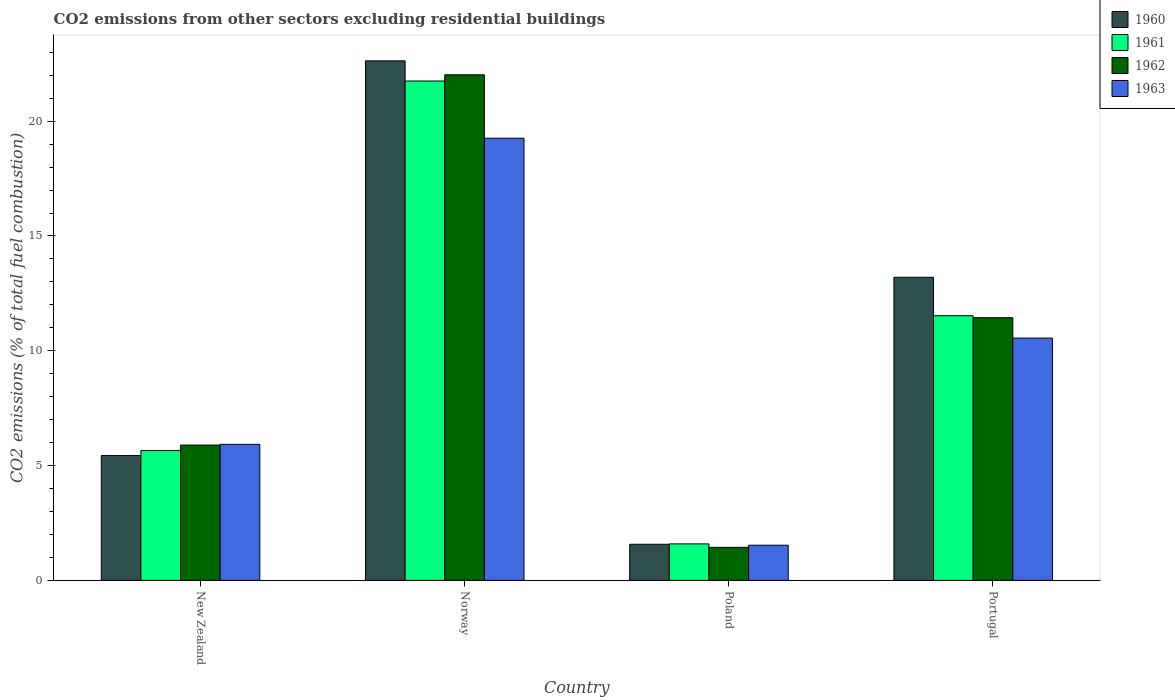Are the number of bars per tick equal to the number of legend labels?
Your response must be concise. Yes. How many bars are there on the 1st tick from the right?
Offer a terse response. 4. What is the label of the 1st group of bars from the left?
Your response must be concise. New Zealand. What is the total CO2 emitted in 1963 in Norway?
Ensure brevity in your answer.  19.26. Across all countries, what is the maximum total CO2 emitted in 1960?
Make the answer very short. 22.63. Across all countries, what is the minimum total CO2 emitted in 1961?
Offer a very short reply. 1.59. In which country was the total CO2 emitted in 1961 maximum?
Your answer should be compact. Norway. What is the total total CO2 emitted in 1961 in the graph?
Ensure brevity in your answer.  40.52. What is the difference between the total CO2 emitted in 1963 in Poland and that in Portugal?
Your answer should be very brief. -9.02. What is the difference between the total CO2 emitted in 1960 in New Zealand and the total CO2 emitted in 1963 in Portugal?
Your answer should be compact. -5.12. What is the average total CO2 emitted in 1961 per country?
Your response must be concise. 10.13. What is the difference between the total CO2 emitted of/in 1962 and total CO2 emitted of/in 1961 in Norway?
Your answer should be very brief. 0.27. In how many countries, is the total CO2 emitted in 1961 greater than 18?
Offer a terse response. 1. What is the ratio of the total CO2 emitted in 1960 in Poland to that in Portugal?
Ensure brevity in your answer.  0.12. Is the difference between the total CO2 emitted in 1962 in New Zealand and Poland greater than the difference between the total CO2 emitted in 1961 in New Zealand and Poland?
Offer a very short reply. Yes. What is the difference between the highest and the second highest total CO2 emitted in 1963?
Provide a succinct answer. -8.7. What is the difference between the highest and the lowest total CO2 emitted in 1962?
Ensure brevity in your answer.  20.58. In how many countries, is the total CO2 emitted in 1963 greater than the average total CO2 emitted in 1963 taken over all countries?
Your answer should be very brief. 2. What does the 2nd bar from the left in New Zealand represents?
Offer a terse response. 1961. What does the 2nd bar from the right in New Zealand represents?
Your response must be concise. 1962. Are all the bars in the graph horizontal?
Offer a very short reply. No. How many countries are there in the graph?
Offer a terse response. 4. What is the difference between two consecutive major ticks on the Y-axis?
Keep it short and to the point. 5. Are the values on the major ticks of Y-axis written in scientific E-notation?
Offer a very short reply. No. Where does the legend appear in the graph?
Your response must be concise. Top right. What is the title of the graph?
Your answer should be very brief. CO2 emissions from other sectors excluding residential buildings. Does "1996" appear as one of the legend labels in the graph?
Ensure brevity in your answer.  No. What is the label or title of the X-axis?
Keep it short and to the point. Country. What is the label or title of the Y-axis?
Your response must be concise. CO2 emissions (% of total fuel combustion). What is the CO2 emissions (% of total fuel combustion) in 1960 in New Zealand?
Make the answer very short. 5.44. What is the CO2 emissions (% of total fuel combustion) of 1961 in New Zealand?
Your answer should be compact. 5.66. What is the CO2 emissions (% of total fuel combustion) of 1962 in New Zealand?
Offer a very short reply. 5.89. What is the CO2 emissions (% of total fuel combustion) of 1963 in New Zealand?
Give a very brief answer. 5.93. What is the CO2 emissions (% of total fuel combustion) of 1960 in Norway?
Provide a succinct answer. 22.63. What is the CO2 emissions (% of total fuel combustion) of 1961 in Norway?
Give a very brief answer. 21.75. What is the CO2 emissions (% of total fuel combustion) of 1962 in Norway?
Provide a succinct answer. 22.02. What is the CO2 emissions (% of total fuel combustion) of 1963 in Norway?
Offer a terse response. 19.26. What is the CO2 emissions (% of total fuel combustion) in 1960 in Poland?
Offer a very short reply. 1.57. What is the CO2 emissions (% of total fuel combustion) of 1961 in Poland?
Make the answer very short. 1.59. What is the CO2 emissions (% of total fuel combustion) of 1962 in Poland?
Provide a short and direct response. 1.44. What is the CO2 emissions (% of total fuel combustion) in 1963 in Poland?
Provide a short and direct response. 1.53. What is the CO2 emissions (% of total fuel combustion) of 1960 in Portugal?
Keep it short and to the point. 13.2. What is the CO2 emissions (% of total fuel combustion) of 1961 in Portugal?
Provide a short and direct response. 11.53. What is the CO2 emissions (% of total fuel combustion) of 1962 in Portugal?
Give a very brief answer. 11.44. What is the CO2 emissions (% of total fuel combustion) of 1963 in Portugal?
Your response must be concise. 10.55. Across all countries, what is the maximum CO2 emissions (% of total fuel combustion) of 1960?
Make the answer very short. 22.63. Across all countries, what is the maximum CO2 emissions (% of total fuel combustion) in 1961?
Your answer should be very brief. 21.75. Across all countries, what is the maximum CO2 emissions (% of total fuel combustion) of 1962?
Provide a succinct answer. 22.02. Across all countries, what is the maximum CO2 emissions (% of total fuel combustion) in 1963?
Your answer should be very brief. 19.26. Across all countries, what is the minimum CO2 emissions (% of total fuel combustion) of 1960?
Your response must be concise. 1.57. Across all countries, what is the minimum CO2 emissions (% of total fuel combustion) of 1961?
Your answer should be very brief. 1.59. Across all countries, what is the minimum CO2 emissions (% of total fuel combustion) of 1962?
Offer a very short reply. 1.44. Across all countries, what is the minimum CO2 emissions (% of total fuel combustion) in 1963?
Make the answer very short. 1.53. What is the total CO2 emissions (% of total fuel combustion) of 1960 in the graph?
Make the answer very short. 42.84. What is the total CO2 emissions (% of total fuel combustion) in 1961 in the graph?
Give a very brief answer. 40.52. What is the total CO2 emissions (% of total fuel combustion) of 1962 in the graph?
Offer a terse response. 40.79. What is the total CO2 emissions (% of total fuel combustion) in 1963 in the graph?
Provide a short and direct response. 37.27. What is the difference between the CO2 emissions (% of total fuel combustion) in 1960 in New Zealand and that in Norway?
Your response must be concise. -17.19. What is the difference between the CO2 emissions (% of total fuel combustion) in 1961 in New Zealand and that in Norway?
Provide a succinct answer. -16.09. What is the difference between the CO2 emissions (% of total fuel combustion) of 1962 in New Zealand and that in Norway?
Your answer should be very brief. -16.13. What is the difference between the CO2 emissions (% of total fuel combustion) of 1963 in New Zealand and that in Norway?
Provide a short and direct response. -13.33. What is the difference between the CO2 emissions (% of total fuel combustion) in 1960 in New Zealand and that in Poland?
Your response must be concise. 3.86. What is the difference between the CO2 emissions (% of total fuel combustion) in 1961 in New Zealand and that in Poland?
Your response must be concise. 4.07. What is the difference between the CO2 emissions (% of total fuel combustion) of 1962 in New Zealand and that in Poland?
Your answer should be compact. 4.45. What is the difference between the CO2 emissions (% of total fuel combustion) of 1963 in New Zealand and that in Poland?
Give a very brief answer. 4.39. What is the difference between the CO2 emissions (% of total fuel combustion) in 1960 in New Zealand and that in Portugal?
Offer a terse response. -7.76. What is the difference between the CO2 emissions (% of total fuel combustion) in 1961 in New Zealand and that in Portugal?
Your answer should be compact. -5.87. What is the difference between the CO2 emissions (% of total fuel combustion) of 1962 in New Zealand and that in Portugal?
Offer a very short reply. -5.55. What is the difference between the CO2 emissions (% of total fuel combustion) in 1963 in New Zealand and that in Portugal?
Provide a succinct answer. -4.63. What is the difference between the CO2 emissions (% of total fuel combustion) in 1960 in Norway and that in Poland?
Your response must be concise. 21.05. What is the difference between the CO2 emissions (% of total fuel combustion) in 1961 in Norway and that in Poland?
Offer a very short reply. 20.16. What is the difference between the CO2 emissions (% of total fuel combustion) of 1962 in Norway and that in Poland?
Ensure brevity in your answer.  20.58. What is the difference between the CO2 emissions (% of total fuel combustion) in 1963 in Norway and that in Poland?
Your answer should be compact. 17.73. What is the difference between the CO2 emissions (% of total fuel combustion) in 1960 in Norway and that in Portugal?
Your answer should be very brief. 9.43. What is the difference between the CO2 emissions (% of total fuel combustion) of 1961 in Norway and that in Portugal?
Provide a short and direct response. 10.22. What is the difference between the CO2 emissions (% of total fuel combustion) in 1962 in Norway and that in Portugal?
Your answer should be compact. 10.58. What is the difference between the CO2 emissions (% of total fuel combustion) of 1963 in Norway and that in Portugal?
Ensure brevity in your answer.  8.7. What is the difference between the CO2 emissions (% of total fuel combustion) of 1960 in Poland and that in Portugal?
Provide a short and direct response. -11.63. What is the difference between the CO2 emissions (% of total fuel combustion) of 1961 in Poland and that in Portugal?
Your answer should be very brief. -9.94. What is the difference between the CO2 emissions (% of total fuel combustion) in 1962 in Poland and that in Portugal?
Give a very brief answer. -10. What is the difference between the CO2 emissions (% of total fuel combustion) of 1963 in Poland and that in Portugal?
Give a very brief answer. -9.02. What is the difference between the CO2 emissions (% of total fuel combustion) in 1960 in New Zealand and the CO2 emissions (% of total fuel combustion) in 1961 in Norway?
Give a very brief answer. -16.31. What is the difference between the CO2 emissions (% of total fuel combustion) of 1960 in New Zealand and the CO2 emissions (% of total fuel combustion) of 1962 in Norway?
Provide a short and direct response. -16.58. What is the difference between the CO2 emissions (% of total fuel combustion) in 1960 in New Zealand and the CO2 emissions (% of total fuel combustion) in 1963 in Norway?
Provide a succinct answer. -13.82. What is the difference between the CO2 emissions (% of total fuel combustion) in 1961 in New Zealand and the CO2 emissions (% of total fuel combustion) in 1962 in Norway?
Provide a short and direct response. -16.36. What is the difference between the CO2 emissions (% of total fuel combustion) of 1961 in New Zealand and the CO2 emissions (% of total fuel combustion) of 1963 in Norway?
Provide a short and direct response. -13.6. What is the difference between the CO2 emissions (% of total fuel combustion) in 1962 in New Zealand and the CO2 emissions (% of total fuel combustion) in 1963 in Norway?
Your response must be concise. -13.36. What is the difference between the CO2 emissions (% of total fuel combustion) in 1960 in New Zealand and the CO2 emissions (% of total fuel combustion) in 1961 in Poland?
Make the answer very short. 3.85. What is the difference between the CO2 emissions (% of total fuel combustion) of 1960 in New Zealand and the CO2 emissions (% of total fuel combustion) of 1962 in Poland?
Provide a succinct answer. 4. What is the difference between the CO2 emissions (% of total fuel combustion) of 1960 in New Zealand and the CO2 emissions (% of total fuel combustion) of 1963 in Poland?
Give a very brief answer. 3.91. What is the difference between the CO2 emissions (% of total fuel combustion) in 1961 in New Zealand and the CO2 emissions (% of total fuel combustion) in 1962 in Poland?
Your response must be concise. 4.22. What is the difference between the CO2 emissions (% of total fuel combustion) in 1961 in New Zealand and the CO2 emissions (% of total fuel combustion) in 1963 in Poland?
Give a very brief answer. 4.12. What is the difference between the CO2 emissions (% of total fuel combustion) in 1962 in New Zealand and the CO2 emissions (% of total fuel combustion) in 1963 in Poland?
Provide a succinct answer. 4.36. What is the difference between the CO2 emissions (% of total fuel combustion) in 1960 in New Zealand and the CO2 emissions (% of total fuel combustion) in 1961 in Portugal?
Your answer should be very brief. -6.09. What is the difference between the CO2 emissions (% of total fuel combustion) of 1960 in New Zealand and the CO2 emissions (% of total fuel combustion) of 1962 in Portugal?
Your response must be concise. -6. What is the difference between the CO2 emissions (% of total fuel combustion) in 1960 in New Zealand and the CO2 emissions (% of total fuel combustion) in 1963 in Portugal?
Provide a short and direct response. -5.12. What is the difference between the CO2 emissions (% of total fuel combustion) in 1961 in New Zealand and the CO2 emissions (% of total fuel combustion) in 1962 in Portugal?
Provide a succinct answer. -5.79. What is the difference between the CO2 emissions (% of total fuel combustion) of 1961 in New Zealand and the CO2 emissions (% of total fuel combustion) of 1963 in Portugal?
Keep it short and to the point. -4.9. What is the difference between the CO2 emissions (% of total fuel combustion) of 1962 in New Zealand and the CO2 emissions (% of total fuel combustion) of 1963 in Portugal?
Offer a terse response. -4.66. What is the difference between the CO2 emissions (% of total fuel combustion) in 1960 in Norway and the CO2 emissions (% of total fuel combustion) in 1961 in Poland?
Your answer should be very brief. 21.04. What is the difference between the CO2 emissions (% of total fuel combustion) of 1960 in Norway and the CO2 emissions (% of total fuel combustion) of 1962 in Poland?
Offer a terse response. 21.19. What is the difference between the CO2 emissions (% of total fuel combustion) of 1960 in Norway and the CO2 emissions (% of total fuel combustion) of 1963 in Poland?
Provide a succinct answer. 21.1. What is the difference between the CO2 emissions (% of total fuel combustion) of 1961 in Norway and the CO2 emissions (% of total fuel combustion) of 1962 in Poland?
Your answer should be very brief. 20.31. What is the difference between the CO2 emissions (% of total fuel combustion) of 1961 in Norway and the CO2 emissions (% of total fuel combustion) of 1963 in Poland?
Your answer should be compact. 20.22. What is the difference between the CO2 emissions (% of total fuel combustion) in 1962 in Norway and the CO2 emissions (% of total fuel combustion) in 1963 in Poland?
Your answer should be very brief. 20.49. What is the difference between the CO2 emissions (% of total fuel combustion) in 1960 in Norway and the CO2 emissions (% of total fuel combustion) in 1961 in Portugal?
Your answer should be compact. 11.1. What is the difference between the CO2 emissions (% of total fuel combustion) in 1960 in Norway and the CO2 emissions (% of total fuel combustion) in 1962 in Portugal?
Keep it short and to the point. 11.19. What is the difference between the CO2 emissions (% of total fuel combustion) of 1960 in Norway and the CO2 emissions (% of total fuel combustion) of 1963 in Portugal?
Your answer should be very brief. 12.07. What is the difference between the CO2 emissions (% of total fuel combustion) of 1961 in Norway and the CO2 emissions (% of total fuel combustion) of 1962 in Portugal?
Offer a terse response. 10.31. What is the difference between the CO2 emissions (% of total fuel combustion) in 1961 in Norway and the CO2 emissions (% of total fuel combustion) in 1963 in Portugal?
Offer a very short reply. 11.2. What is the difference between the CO2 emissions (% of total fuel combustion) in 1962 in Norway and the CO2 emissions (% of total fuel combustion) in 1963 in Portugal?
Keep it short and to the point. 11.47. What is the difference between the CO2 emissions (% of total fuel combustion) in 1960 in Poland and the CO2 emissions (% of total fuel combustion) in 1961 in Portugal?
Give a very brief answer. -9.95. What is the difference between the CO2 emissions (% of total fuel combustion) in 1960 in Poland and the CO2 emissions (% of total fuel combustion) in 1962 in Portugal?
Provide a short and direct response. -9.87. What is the difference between the CO2 emissions (% of total fuel combustion) of 1960 in Poland and the CO2 emissions (% of total fuel combustion) of 1963 in Portugal?
Give a very brief answer. -8.98. What is the difference between the CO2 emissions (% of total fuel combustion) of 1961 in Poland and the CO2 emissions (% of total fuel combustion) of 1962 in Portugal?
Offer a very short reply. -9.85. What is the difference between the CO2 emissions (% of total fuel combustion) in 1961 in Poland and the CO2 emissions (% of total fuel combustion) in 1963 in Portugal?
Make the answer very short. -8.96. What is the difference between the CO2 emissions (% of total fuel combustion) of 1962 in Poland and the CO2 emissions (% of total fuel combustion) of 1963 in Portugal?
Your answer should be very brief. -9.11. What is the average CO2 emissions (% of total fuel combustion) of 1960 per country?
Offer a very short reply. 10.71. What is the average CO2 emissions (% of total fuel combustion) of 1961 per country?
Offer a very short reply. 10.13. What is the average CO2 emissions (% of total fuel combustion) in 1962 per country?
Your answer should be very brief. 10.2. What is the average CO2 emissions (% of total fuel combustion) in 1963 per country?
Offer a very short reply. 9.32. What is the difference between the CO2 emissions (% of total fuel combustion) in 1960 and CO2 emissions (% of total fuel combustion) in 1961 in New Zealand?
Your answer should be compact. -0.22. What is the difference between the CO2 emissions (% of total fuel combustion) of 1960 and CO2 emissions (% of total fuel combustion) of 1962 in New Zealand?
Your response must be concise. -0.46. What is the difference between the CO2 emissions (% of total fuel combustion) in 1960 and CO2 emissions (% of total fuel combustion) in 1963 in New Zealand?
Your answer should be very brief. -0.49. What is the difference between the CO2 emissions (% of total fuel combustion) in 1961 and CO2 emissions (% of total fuel combustion) in 1962 in New Zealand?
Provide a short and direct response. -0.24. What is the difference between the CO2 emissions (% of total fuel combustion) in 1961 and CO2 emissions (% of total fuel combustion) in 1963 in New Zealand?
Make the answer very short. -0.27. What is the difference between the CO2 emissions (% of total fuel combustion) in 1962 and CO2 emissions (% of total fuel combustion) in 1963 in New Zealand?
Your answer should be very brief. -0.03. What is the difference between the CO2 emissions (% of total fuel combustion) of 1960 and CO2 emissions (% of total fuel combustion) of 1961 in Norway?
Your response must be concise. 0.88. What is the difference between the CO2 emissions (% of total fuel combustion) in 1960 and CO2 emissions (% of total fuel combustion) in 1962 in Norway?
Provide a succinct answer. 0.61. What is the difference between the CO2 emissions (% of total fuel combustion) of 1960 and CO2 emissions (% of total fuel combustion) of 1963 in Norway?
Your answer should be compact. 3.37. What is the difference between the CO2 emissions (% of total fuel combustion) of 1961 and CO2 emissions (% of total fuel combustion) of 1962 in Norway?
Give a very brief answer. -0.27. What is the difference between the CO2 emissions (% of total fuel combustion) of 1961 and CO2 emissions (% of total fuel combustion) of 1963 in Norway?
Your response must be concise. 2.49. What is the difference between the CO2 emissions (% of total fuel combustion) in 1962 and CO2 emissions (% of total fuel combustion) in 1963 in Norway?
Provide a short and direct response. 2.76. What is the difference between the CO2 emissions (% of total fuel combustion) of 1960 and CO2 emissions (% of total fuel combustion) of 1961 in Poland?
Keep it short and to the point. -0.02. What is the difference between the CO2 emissions (% of total fuel combustion) in 1960 and CO2 emissions (% of total fuel combustion) in 1962 in Poland?
Make the answer very short. 0.13. What is the difference between the CO2 emissions (% of total fuel combustion) in 1960 and CO2 emissions (% of total fuel combustion) in 1963 in Poland?
Offer a very short reply. 0.04. What is the difference between the CO2 emissions (% of total fuel combustion) in 1961 and CO2 emissions (% of total fuel combustion) in 1962 in Poland?
Ensure brevity in your answer.  0.15. What is the difference between the CO2 emissions (% of total fuel combustion) of 1961 and CO2 emissions (% of total fuel combustion) of 1963 in Poland?
Your answer should be very brief. 0.06. What is the difference between the CO2 emissions (% of total fuel combustion) in 1962 and CO2 emissions (% of total fuel combustion) in 1963 in Poland?
Keep it short and to the point. -0.09. What is the difference between the CO2 emissions (% of total fuel combustion) in 1960 and CO2 emissions (% of total fuel combustion) in 1961 in Portugal?
Provide a short and direct response. 1.67. What is the difference between the CO2 emissions (% of total fuel combustion) of 1960 and CO2 emissions (% of total fuel combustion) of 1962 in Portugal?
Offer a very short reply. 1.76. What is the difference between the CO2 emissions (% of total fuel combustion) of 1960 and CO2 emissions (% of total fuel combustion) of 1963 in Portugal?
Your answer should be compact. 2.65. What is the difference between the CO2 emissions (% of total fuel combustion) in 1961 and CO2 emissions (% of total fuel combustion) in 1962 in Portugal?
Your answer should be very brief. 0.09. What is the difference between the CO2 emissions (% of total fuel combustion) in 1962 and CO2 emissions (% of total fuel combustion) in 1963 in Portugal?
Offer a very short reply. 0.89. What is the ratio of the CO2 emissions (% of total fuel combustion) of 1960 in New Zealand to that in Norway?
Your response must be concise. 0.24. What is the ratio of the CO2 emissions (% of total fuel combustion) of 1961 in New Zealand to that in Norway?
Give a very brief answer. 0.26. What is the ratio of the CO2 emissions (% of total fuel combustion) in 1962 in New Zealand to that in Norway?
Make the answer very short. 0.27. What is the ratio of the CO2 emissions (% of total fuel combustion) of 1963 in New Zealand to that in Norway?
Provide a succinct answer. 0.31. What is the ratio of the CO2 emissions (% of total fuel combustion) of 1960 in New Zealand to that in Poland?
Keep it short and to the point. 3.46. What is the ratio of the CO2 emissions (% of total fuel combustion) in 1961 in New Zealand to that in Poland?
Your response must be concise. 3.56. What is the ratio of the CO2 emissions (% of total fuel combustion) of 1962 in New Zealand to that in Poland?
Provide a short and direct response. 4.1. What is the ratio of the CO2 emissions (% of total fuel combustion) of 1963 in New Zealand to that in Poland?
Keep it short and to the point. 3.87. What is the ratio of the CO2 emissions (% of total fuel combustion) of 1960 in New Zealand to that in Portugal?
Make the answer very short. 0.41. What is the ratio of the CO2 emissions (% of total fuel combustion) of 1961 in New Zealand to that in Portugal?
Ensure brevity in your answer.  0.49. What is the ratio of the CO2 emissions (% of total fuel combustion) in 1962 in New Zealand to that in Portugal?
Provide a short and direct response. 0.52. What is the ratio of the CO2 emissions (% of total fuel combustion) in 1963 in New Zealand to that in Portugal?
Provide a short and direct response. 0.56. What is the ratio of the CO2 emissions (% of total fuel combustion) in 1960 in Norway to that in Poland?
Your answer should be very brief. 14.38. What is the ratio of the CO2 emissions (% of total fuel combustion) in 1961 in Norway to that in Poland?
Your answer should be very brief. 13.68. What is the ratio of the CO2 emissions (% of total fuel combustion) in 1962 in Norway to that in Poland?
Your response must be concise. 15.3. What is the ratio of the CO2 emissions (% of total fuel combustion) in 1963 in Norway to that in Poland?
Offer a terse response. 12.57. What is the ratio of the CO2 emissions (% of total fuel combustion) of 1960 in Norway to that in Portugal?
Your answer should be very brief. 1.71. What is the ratio of the CO2 emissions (% of total fuel combustion) in 1961 in Norway to that in Portugal?
Your answer should be very brief. 1.89. What is the ratio of the CO2 emissions (% of total fuel combustion) of 1962 in Norway to that in Portugal?
Ensure brevity in your answer.  1.92. What is the ratio of the CO2 emissions (% of total fuel combustion) of 1963 in Norway to that in Portugal?
Your response must be concise. 1.82. What is the ratio of the CO2 emissions (% of total fuel combustion) of 1960 in Poland to that in Portugal?
Provide a succinct answer. 0.12. What is the ratio of the CO2 emissions (% of total fuel combustion) of 1961 in Poland to that in Portugal?
Ensure brevity in your answer.  0.14. What is the ratio of the CO2 emissions (% of total fuel combustion) in 1962 in Poland to that in Portugal?
Provide a succinct answer. 0.13. What is the ratio of the CO2 emissions (% of total fuel combustion) in 1963 in Poland to that in Portugal?
Ensure brevity in your answer.  0.15. What is the difference between the highest and the second highest CO2 emissions (% of total fuel combustion) in 1960?
Offer a terse response. 9.43. What is the difference between the highest and the second highest CO2 emissions (% of total fuel combustion) of 1961?
Ensure brevity in your answer.  10.22. What is the difference between the highest and the second highest CO2 emissions (% of total fuel combustion) in 1962?
Give a very brief answer. 10.58. What is the difference between the highest and the second highest CO2 emissions (% of total fuel combustion) in 1963?
Ensure brevity in your answer.  8.7. What is the difference between the highest and the lowest CO2 emissions (% of total fuel combustion) in 1960?
Offer a terse response. 21.05. What is the difference between the highest and the lowest CO2 emissions (% of total fuel combustion) in 1961?
Keep it short and to the point. 20.16. What is the difference between the highest and the lowest CO2 emissions (% of total fuel combustion) of 1962?
Give a very brief answer. 20.58. What is the difference between the highest and the lowest CO2 emissions (% of total fuel combustion) of 1963?
Give a very brief answer. 17.73. 